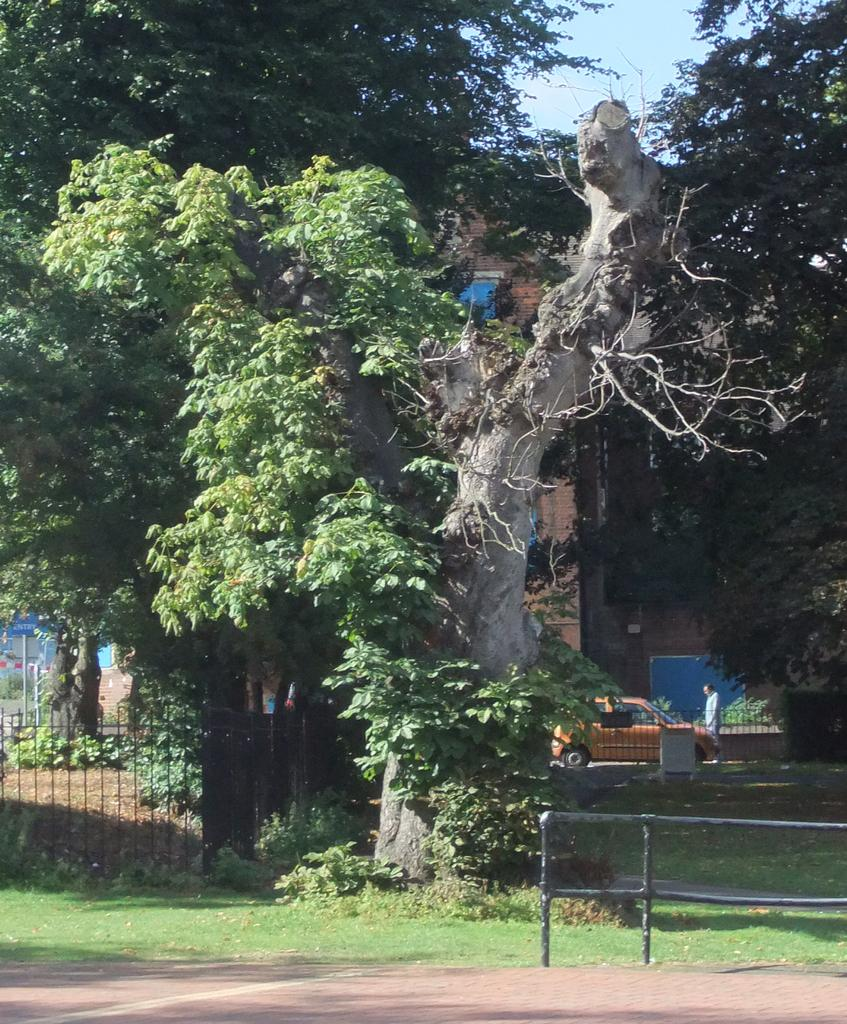What type of plant can be seen on the grass in the image? There is a tree on the grass in the image. What is located behind the tree? There is a fence behind the tree. What mode of transportation is visible in the image? There is a car in the image. What type of structure can be seen in the image? There is a building in the image. What type of trail can be seen in the image? There is no trail present in the image. What scientific theory is being discussed in the image? There is no discussion of a scientific theory in the image. 